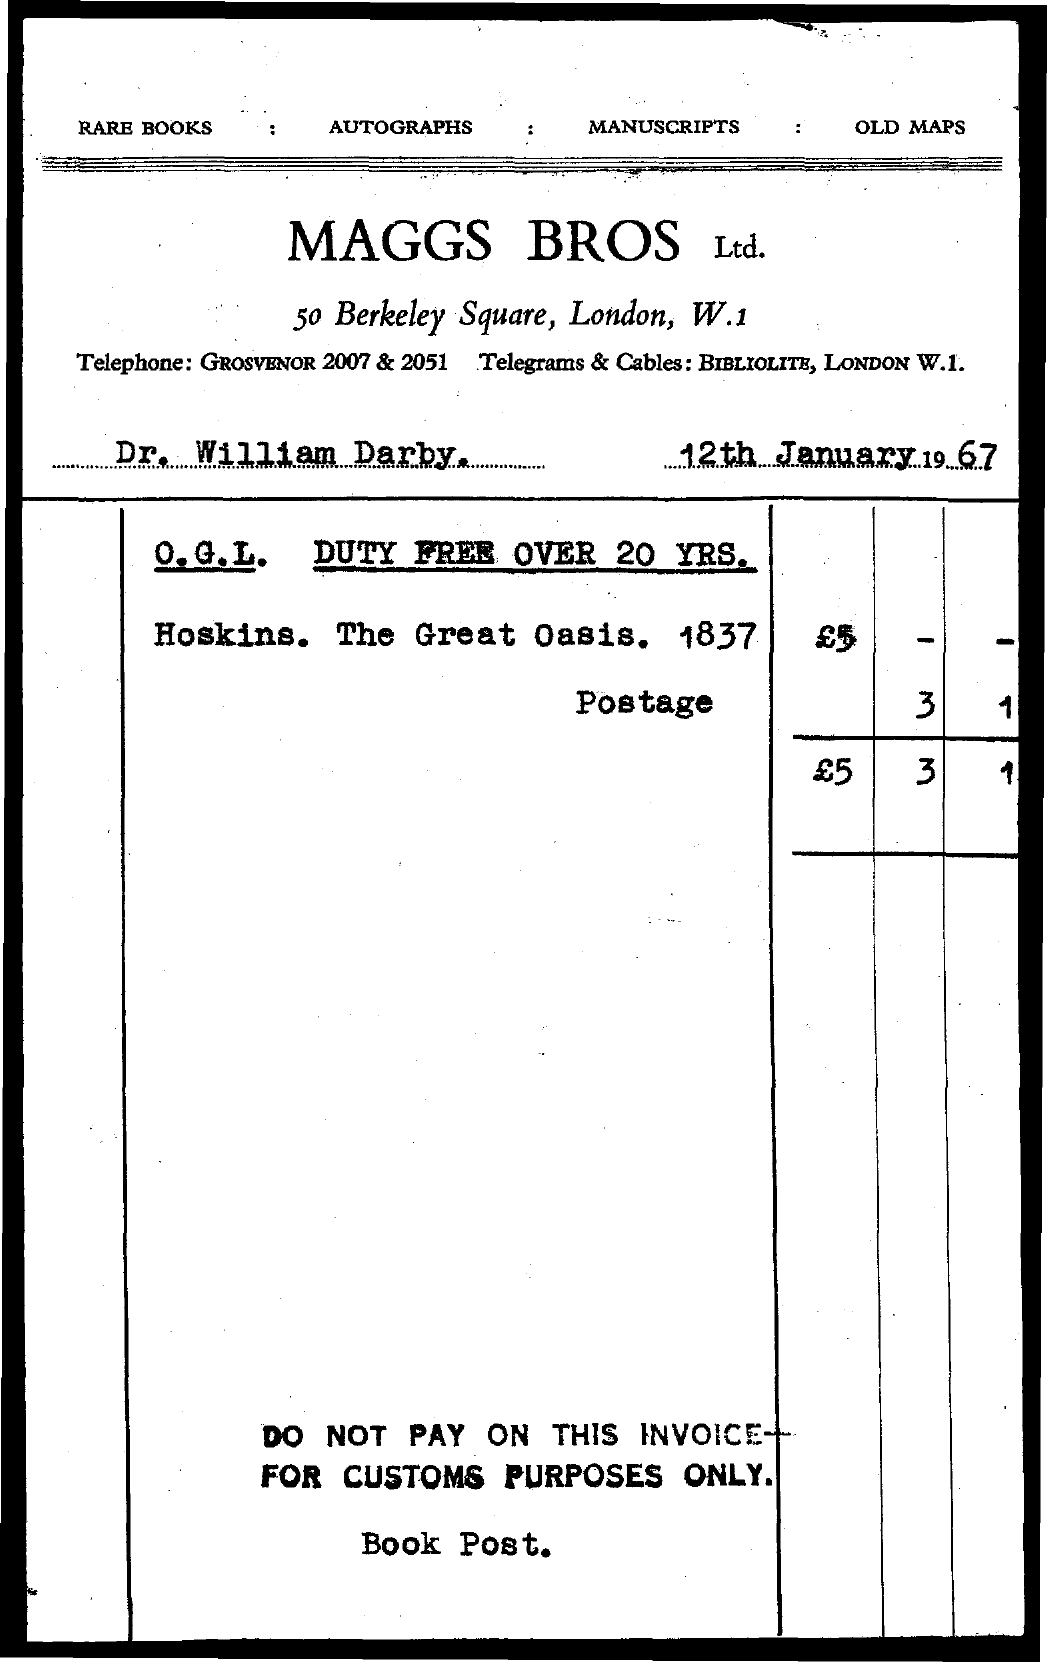List a handful of essential elements in this visual. The date mentioned in the document is January 12th, 1967. The name of the organization involved in this matter is Maggs Bros Ltd. 